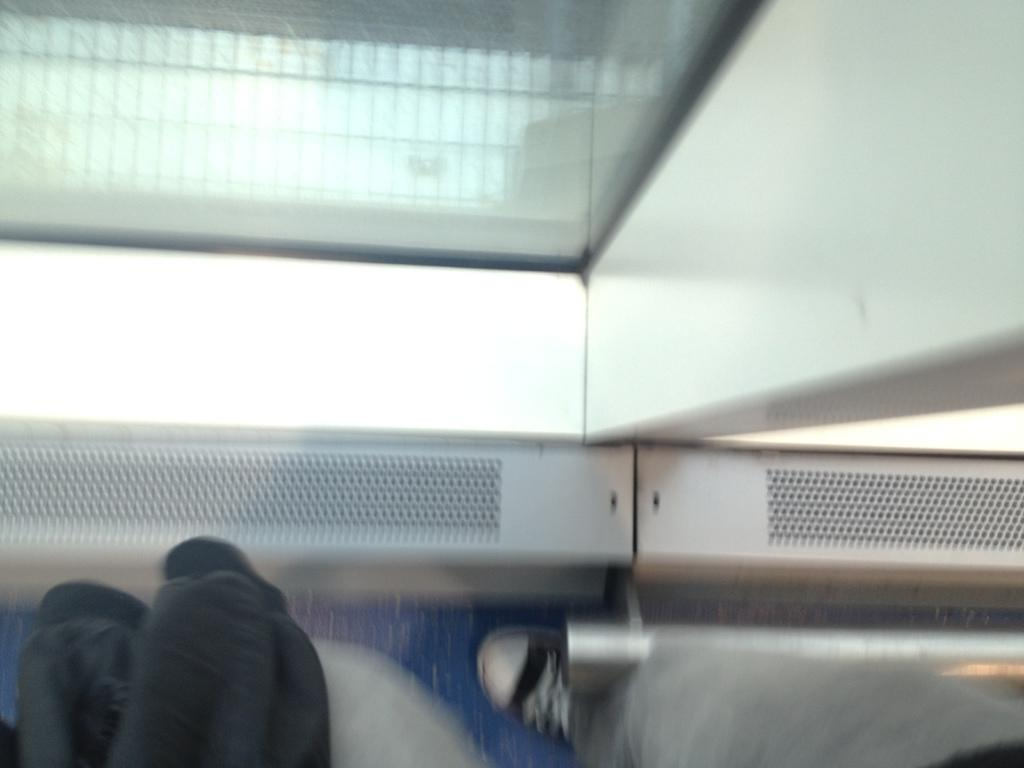What part of a person's body is visible in the image? There is a person's leg visible in the image. What is the person's leg wearing? The leg is wearing a shoe. What type of bird is sitting on the person's leg in the image? There is no bird present on the person's leg in the image. 